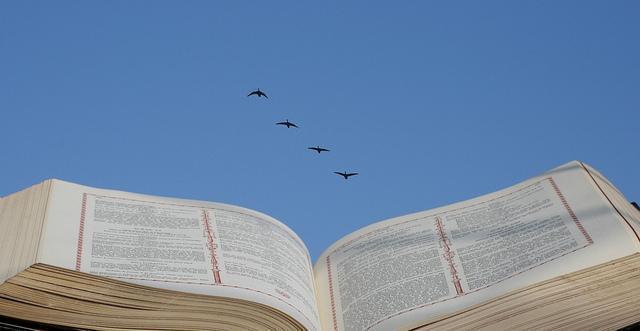Birds seen here are likely doing what?
Select the accurate answer and provide explanation: 'Answer: answer
Rationale: rationale.'
Options: Attacking, flyover, migrating, landing. Answer: migrating.
Rationale: The birds are going to another place to rest. 